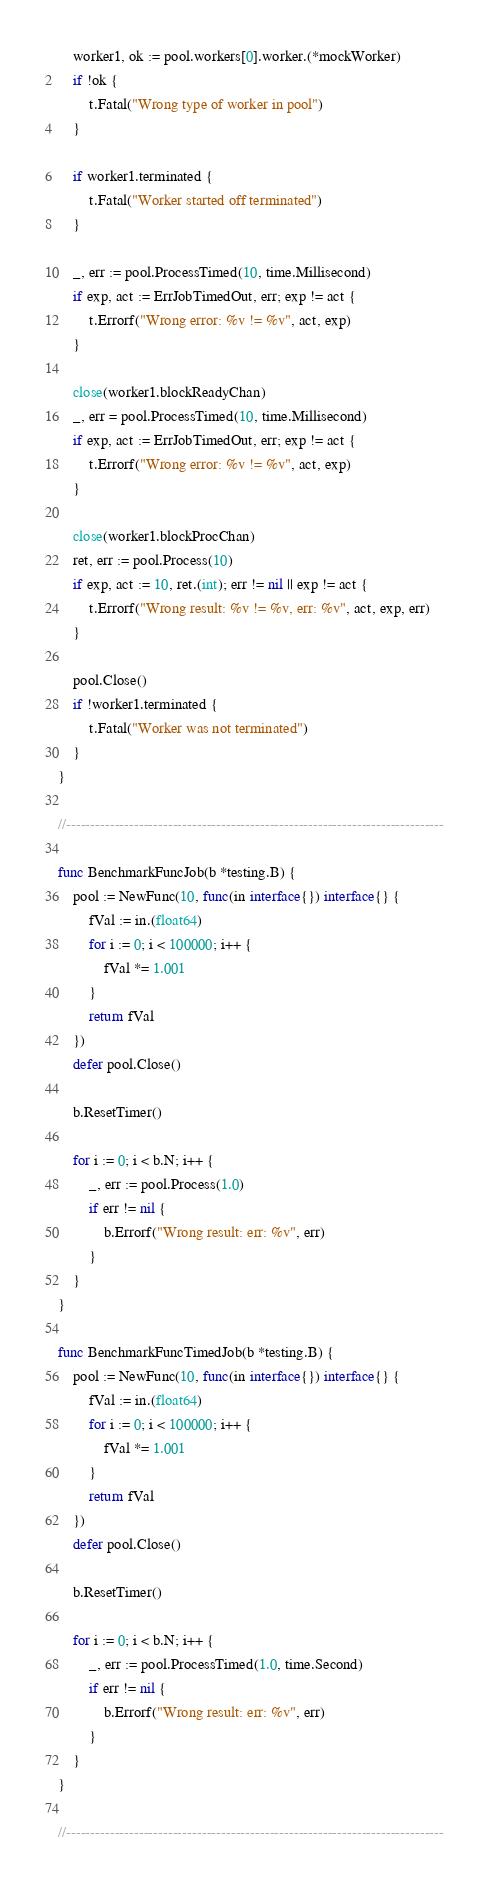<code> <loc_0><loc_0><loc_500><loc_500><_Go_>	worker1, ok := pool.workers[0].worker.(*mockWorker)
	if !ok {
		t.Fatal("Wrong type of worker in pool")
	}

	if worker1.terminated {
		t.Fatal("Worker started off terminated")
	}

	_, err := pool.ProcessTimed(10, time.Millisecond)
	if exp, act := ErrJobTimedOut, err; exp != act {
		t.Errorf("Wrong error: %v != %v", act, exp)
	}

	close(worker1.blockReadyChan)
	_, err = pool.ProcessTimed(10, time.Millisecond)
	if exp, act := ErrJobTimedOut, err; exp != act {
		t.Errorf("Wrong error: %v != %v", act, exp)
	}

	close(worker1.blockProcChan)
	ret, err := pool.Process(10)
	if exp, act := 10, ret.(int); err != nil || exp != act {
		t.Errorf("Wrong result: %v != %v, err: %v", act, exp, err)
	}

	pool.Close()
	if !worker1.terminated {
		t.Fatal("Worker was not terminated")
	}
}

//------------------------------------------------------------------------------

func BenchmarkFuncJob(b *testing.B) {
	pool := NewFunc(10, func(in interface{}) interface{} {
		fVal := in.(float64)
		for i := 0; i < 100000; i++ {
			fVal *= 1.001
		}
		return fVal
	})
	defer pool.Close()

	b.ResetTimer()

	for i := 0; i < b.N; i++ {
		_, err := pool.Process(1.0)
		if err != nil {
			b.Errorf("Wrong result: err: %v", err)
		}
	}
}

func BenchmarkFuncTimedJob(b *testing.B) {
	pool := NewFunc(10, func(in interface{}) interface{} {
		fVal := in.(float64)
		for i := 0; i < 100000; i++ {
			fVal *= 1.001
		}
		return fVal
	})
	defer pool.Close()

	b.ResetTimer()

	for i := 0; i < b.N; i++ {
		_, err := pool.ProcessTimed(1.0, time.Second)
		if err != nil {
			b.Errorf("Wrong result: err: %v", err)
		}
	}
}

//------------------------------------------------------------------------------
</code> 